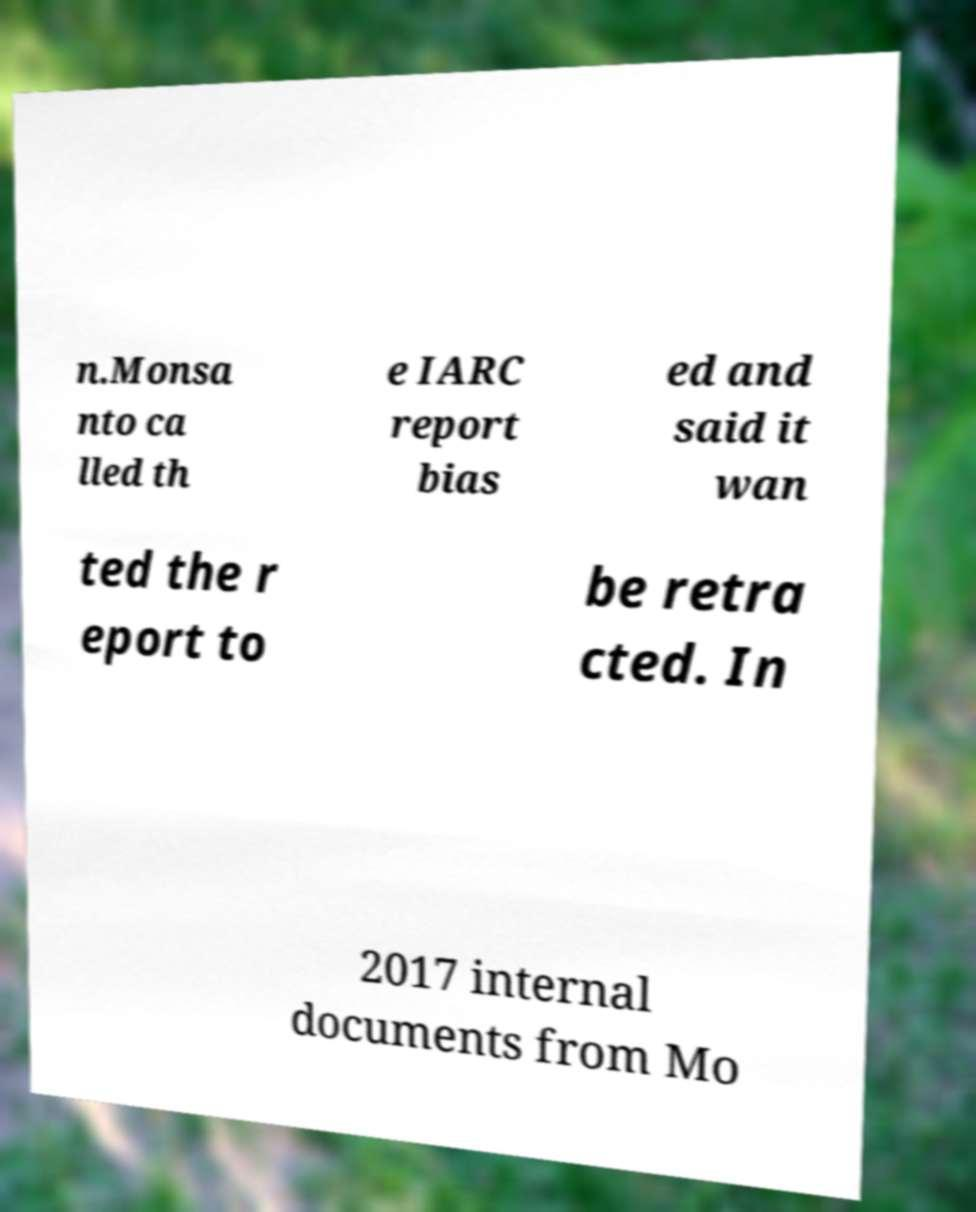What messages or text are displayed in this image? I need them in a readable, typed format. n.Monsa nto ca lled th e IARC report bias ed and said it wan ted the r eport to be retra cted. In 2017 internal documents from Mo 